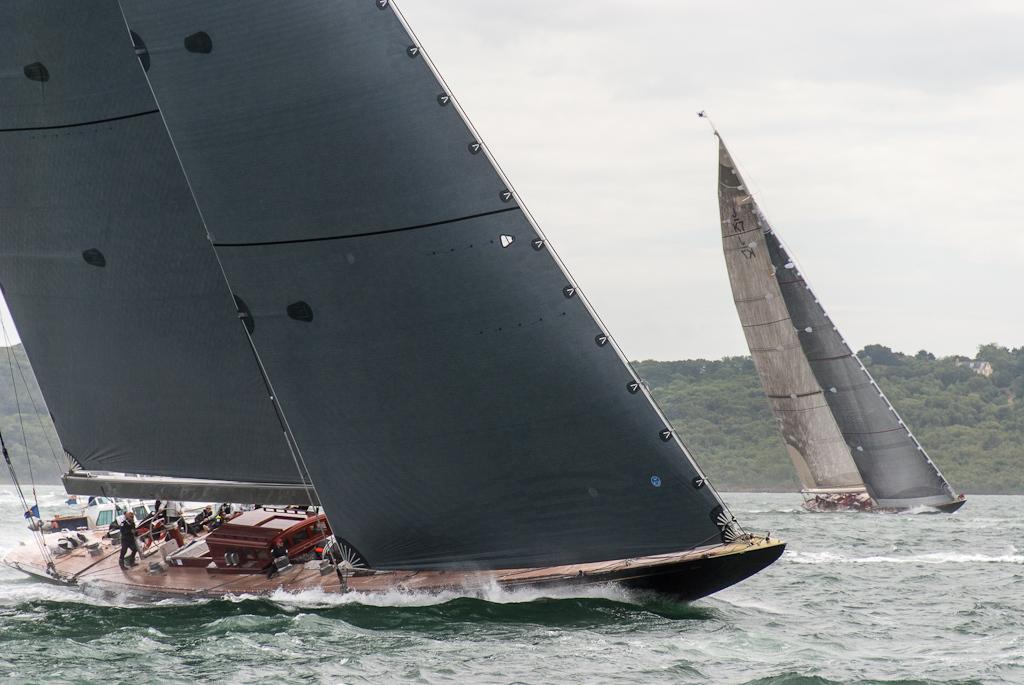In one or two sentences, can you explain what this image depicts? In this picture, we can see a few people sailing in boat, and we can see some objects on boat, we can see water, trees, and the sky with clouds. 